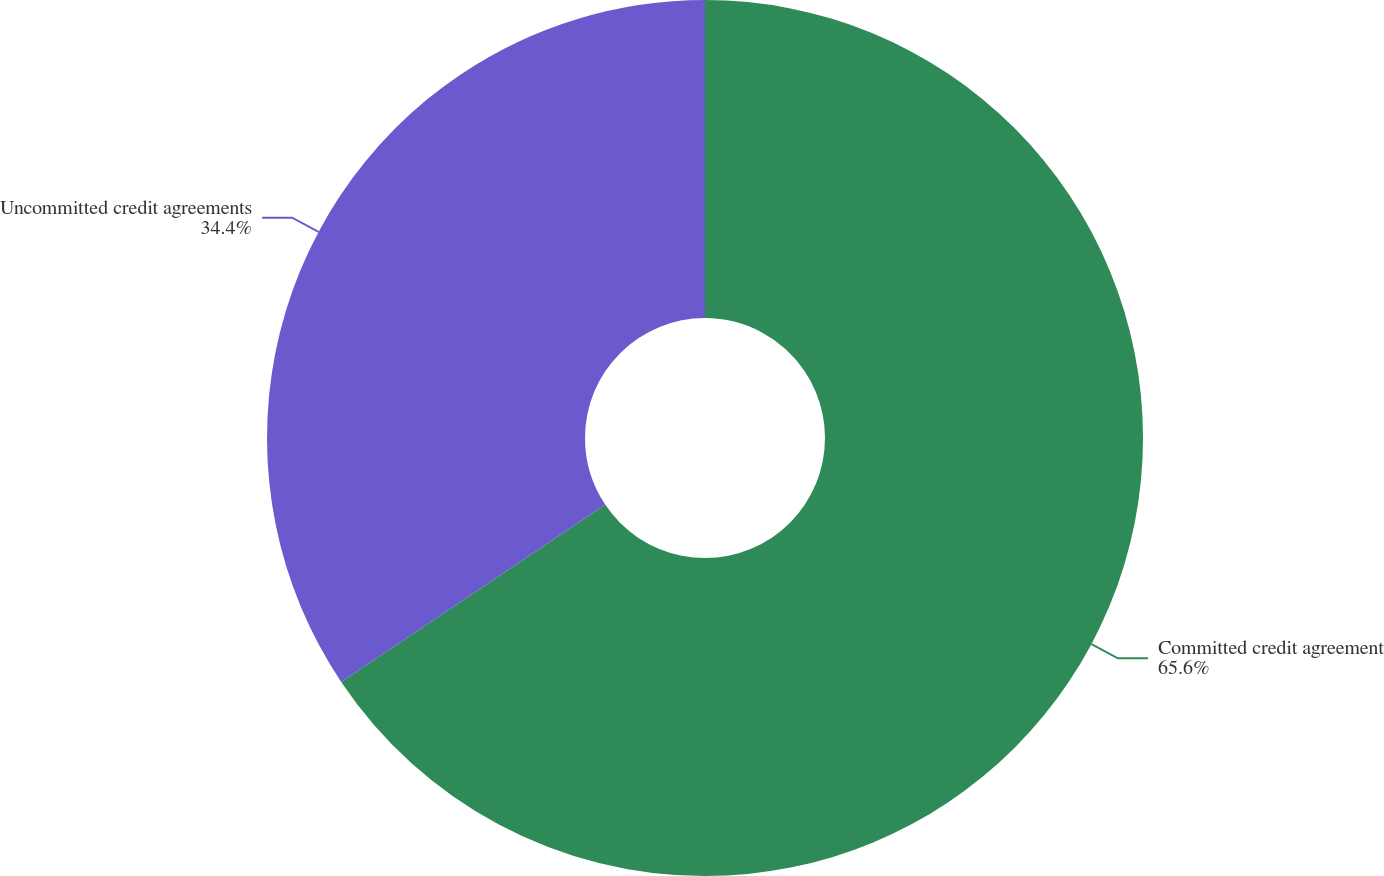Convert chart to OTSL. <chart><loc_0><loc_0><loc_500><loc_500><pie_chart><fcel>Committed credit agreement<fcel>Uncommitted credit agreements<nl><fcel>65.6%<fcel>34.4%<nl></chart> 